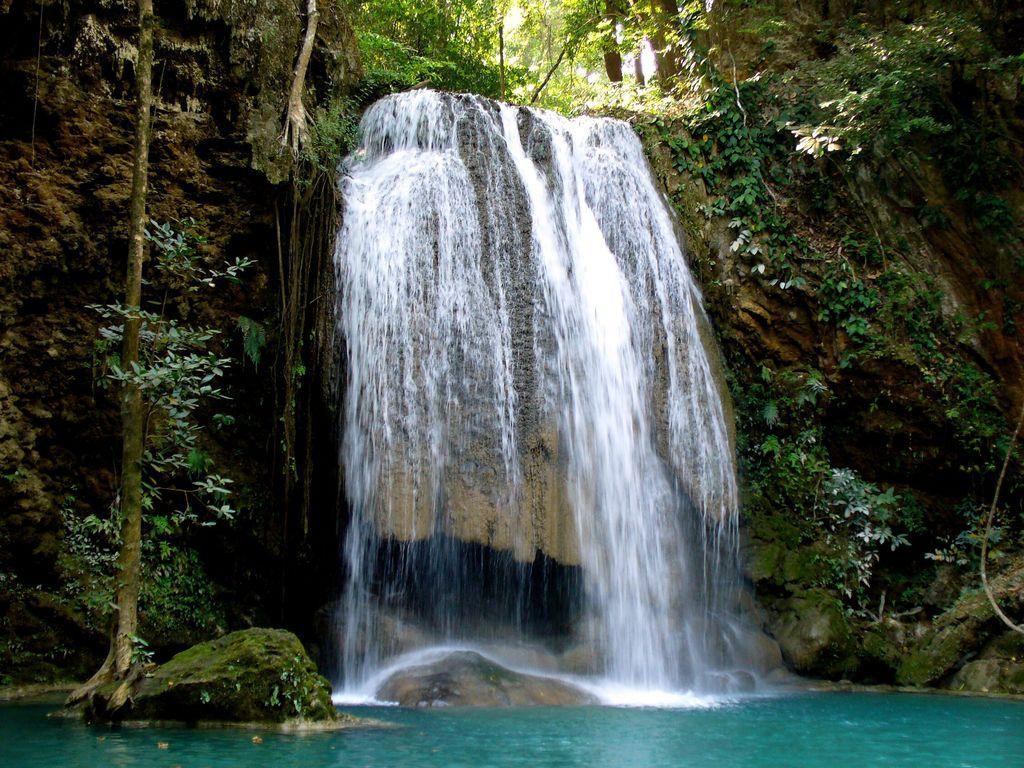Can you describe this image briefly? In the center of the image we can see waterfall. On the right and left side of the image we can see trees and plants. At the bottom of image there is water. 